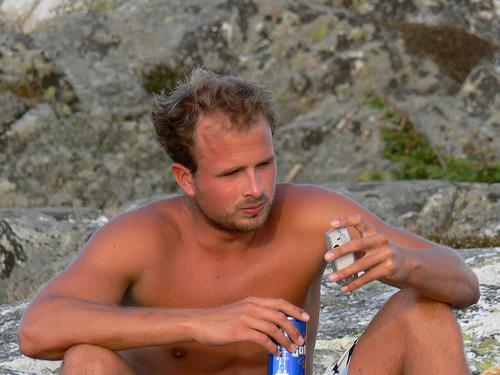Question: what electronic device is in photo?
Choices:
A. Camera.
B. Cell phone.
C. Mp3 player.
D. Laptop.
Answer with the letter. Answer: B Question: what color is the can in man's hand?
Choices:
A. Black.
B. Blue.
C. Silver.
D. White.
Answer with the letter. Answer: B Question: how many drinks are there?
Choices:
A. 2.
B. 3.
C. 1.
D. 6.
Answer with the letter. Answer: C Question: where is the drink?
Choices:
A. On the table.
B. On a coaster.
C. In man's hand.
D. In the woman's hand.
Answer with the letter. Answer: C 